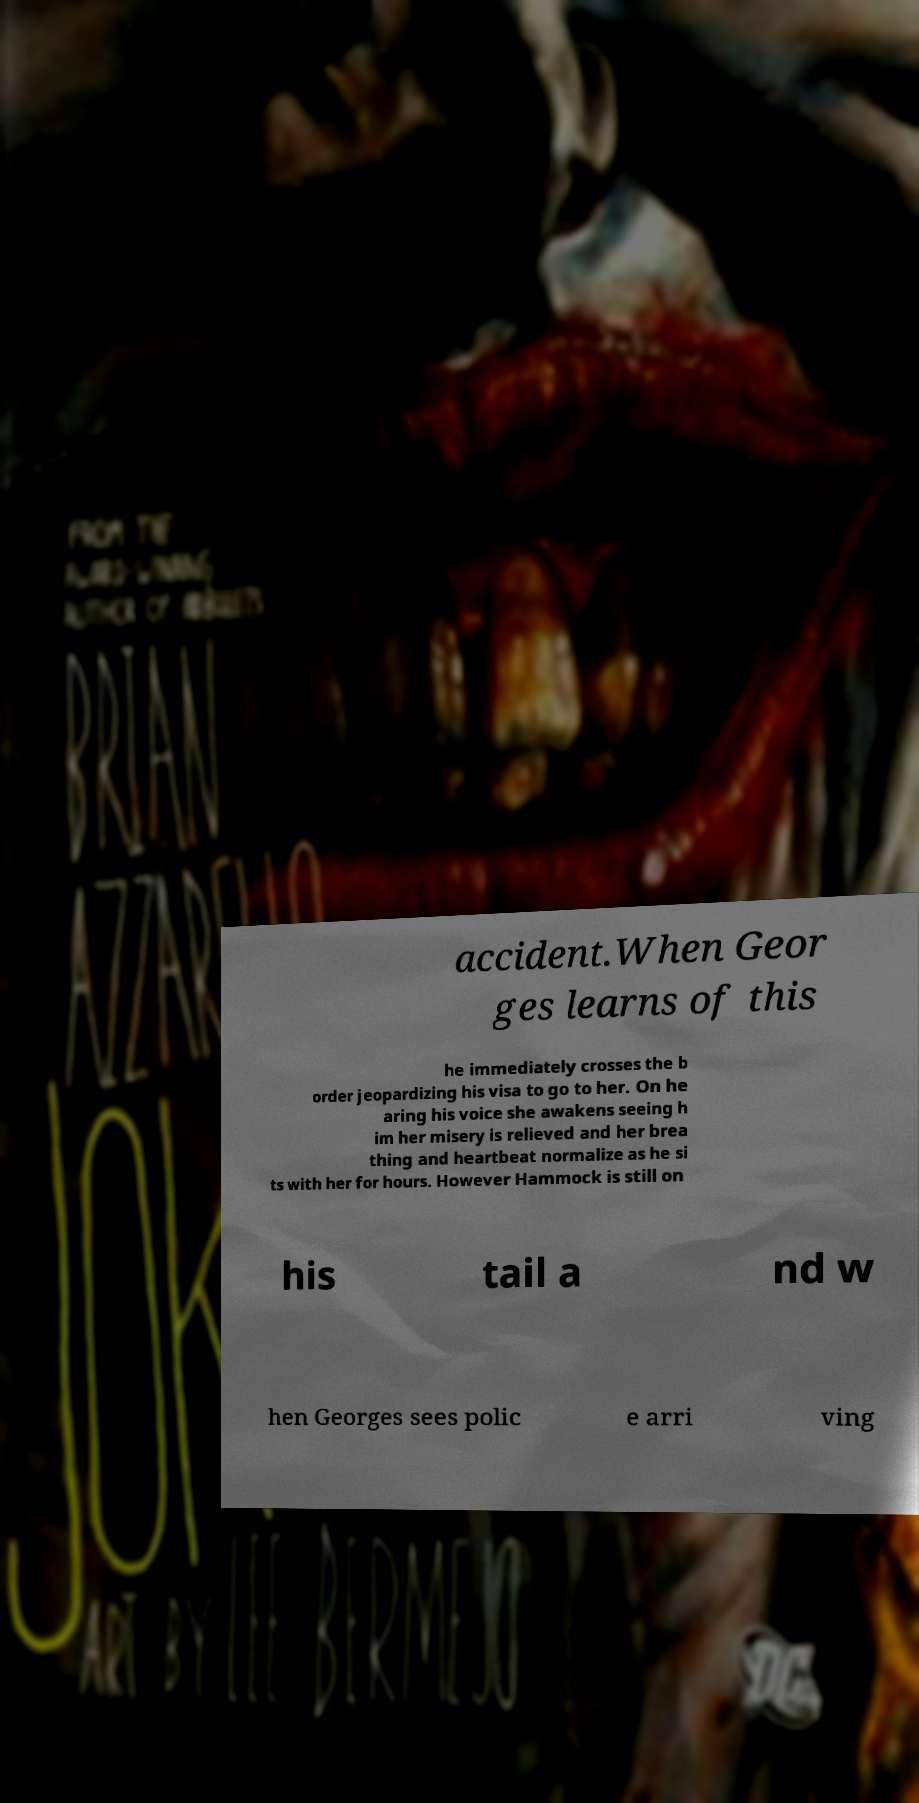Could you extract and type out the text from this image? accident.When Geor ges learns of this he immediately crosses the b order jeopardizing his visa to go to her. On he aring his voice she awakens seeing h im her misery is relieved and her brea thing and heartbeat normalize as he si ts with her for hours. However Hammock is still on his tail a nd w hen Georges sees polic e arri ving 